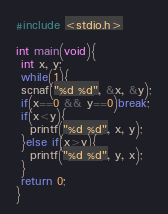Convert code to text. <code><loc_0><loc_0><loc_500><loc_500><_C++_>#include <stdio.h>

int main(void){
 int x, y;
 while(1){
 scnaf("%d %d", &x, &y);
 if(x==0 && y==0)break;
 if(x<y){
   printf("%d %d", x, y);
 }else if(x>y){
   printf("%d %d", y, x);
 }
 return 0;
}
</code> 